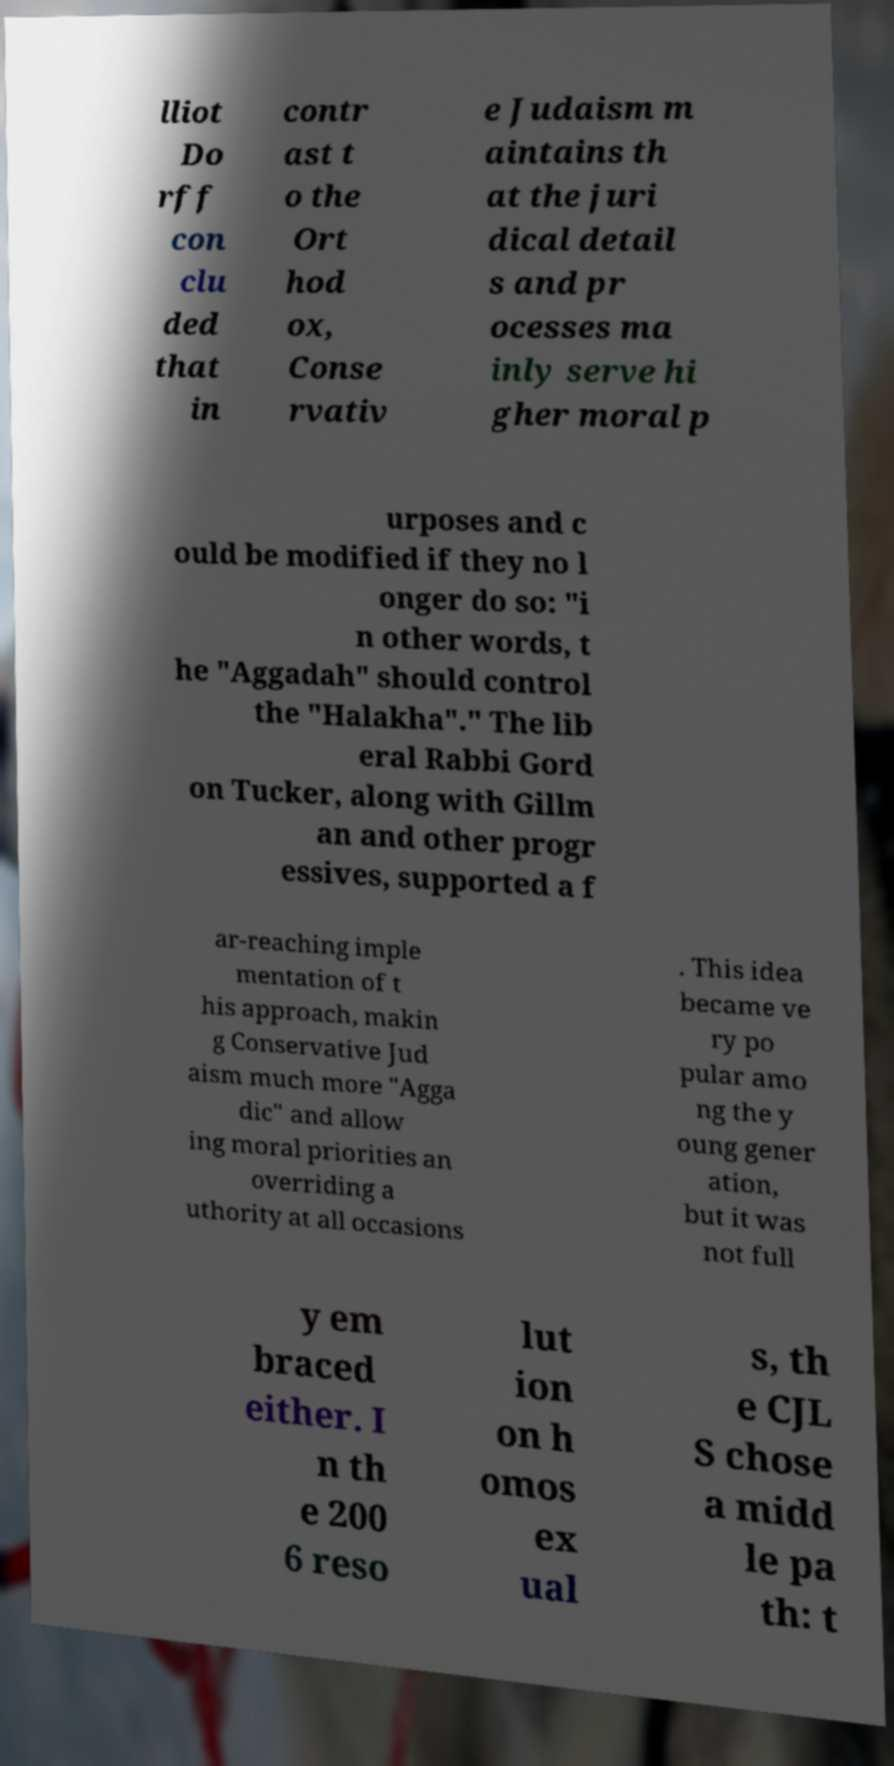Could you extract and type out the text from this image? lliot Do rff con clu ded that in contr ast t o the Ort hod ox, Conse rvativ e Judaism m aintains th at the juri dical detail s and pr ocesses ma inly serve hi gher moral p urposes and c ould be modified if they no l onger do so: "i n other words, t he "Aggadah" should control the "Halakha"." The lib eral Rabbi Gord on Tucker, along with Gillm an and other progr essives, supported a f ar-reaching imple mentation of t his approach, makin g Conservative Jud aism much more "Agga dic" and allow ing moral priorities an overriding a uthority at all occasions . This idea became ve ry po pular amo ng the y oung gener ation, but it was not full y em braced either. I n th e 200 6 reso lut ion on h omos ex ual s, th e CJL S chose a midd le pa th: t 